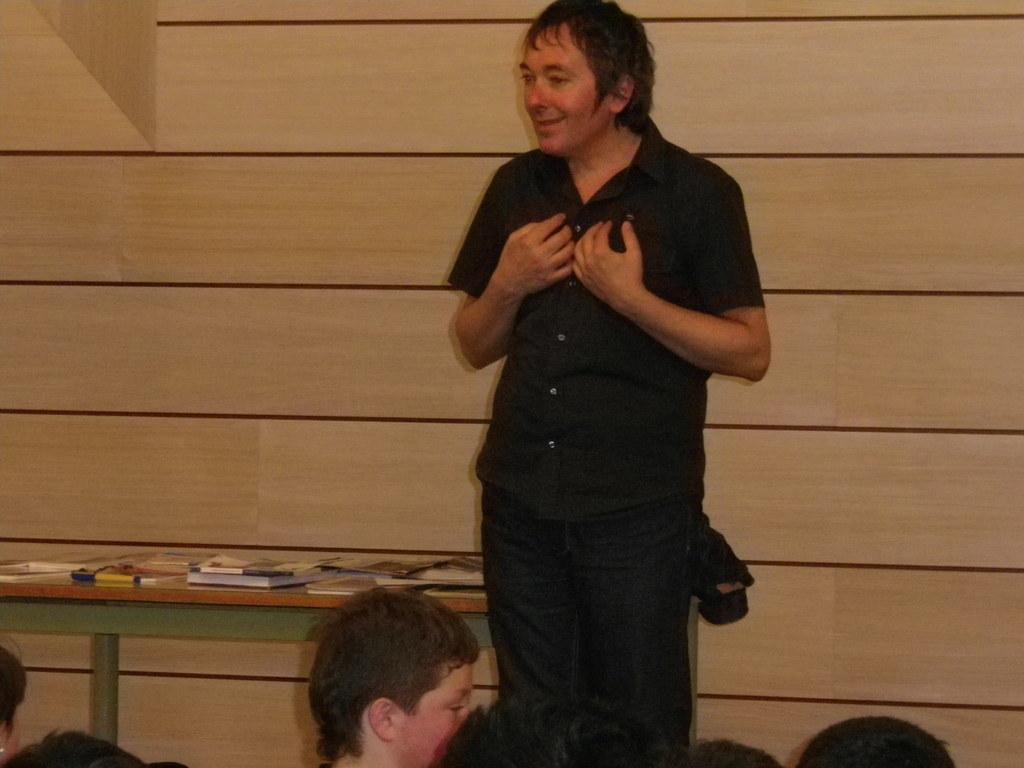Please provide a concise description of this image. In this picture we can see a group of people where a man standing and smiling, table with books on it and in the background we can see wall. 